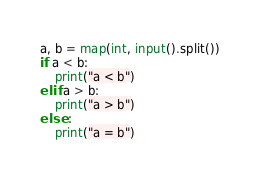<code> <loc_0><loc_0><loc_500><loc_500><_Python_>a, b = map(int, input().split())
if a < b:
    print("a < b")
elif a > b:
    print("a > b")
else :
    print("a = b")

</code> 